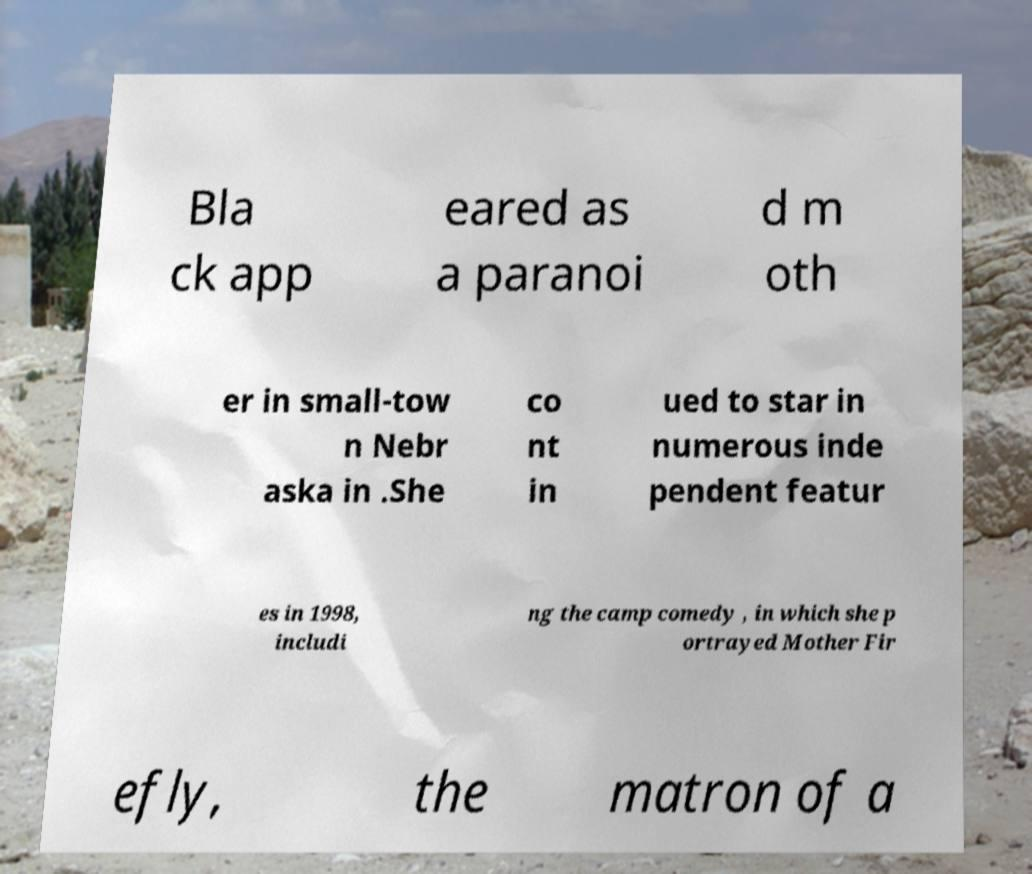Please read and relay the text visible in this image. What does it say? Bla ck app eared as a paranoi d m oth er in small-tow n Nebr aska in .She co nt in ued to star in numerous inde pendent featur es in 1998, includi ng the camp comedy , in which she p ortrayed Mother Fir efly, the matron of a 